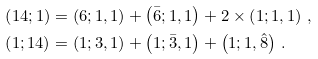Convert formula to latex. <formula><loc_0><loc_0><loc_500><loc_500>\left ( 1 4 ; 1 \right ) & = \left ( 6 ; 1 , 1 \right ) + \left ( \bar { 6 } ; 1 , 1 \right ) + 2 \times \left ( 1 ; 1 , 1 \right ) \, , \\ \left ( 1 ; 1 4 \right ) & = \left ( 1 ; 3 , 1 \right ) + \left ( 1 ; \bar { 3 } , 1 \right ) + \left ( 1 ; 1 , \hat { 8 } \right ) \, .</formula> 